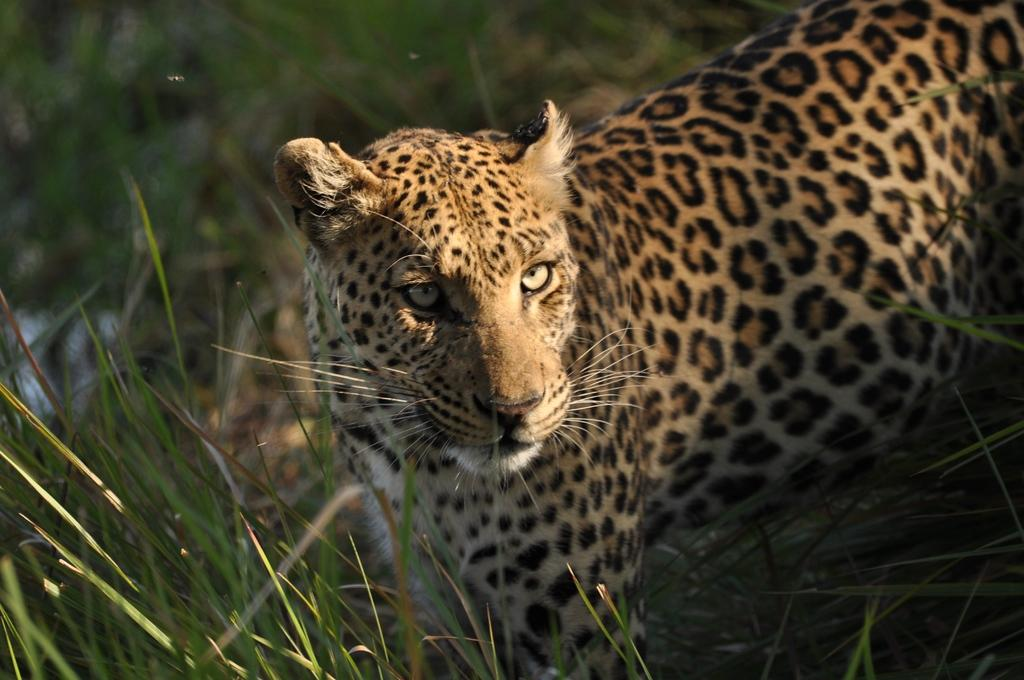What type of vegetation can be seen in the image? There is grass in the image. What type of voice can be heard coming from the grass in the image? There is no voice present in the image, as it features only grass. Is there a boat visible in the image? No, there is no boat present in the image; it only contains grass. 